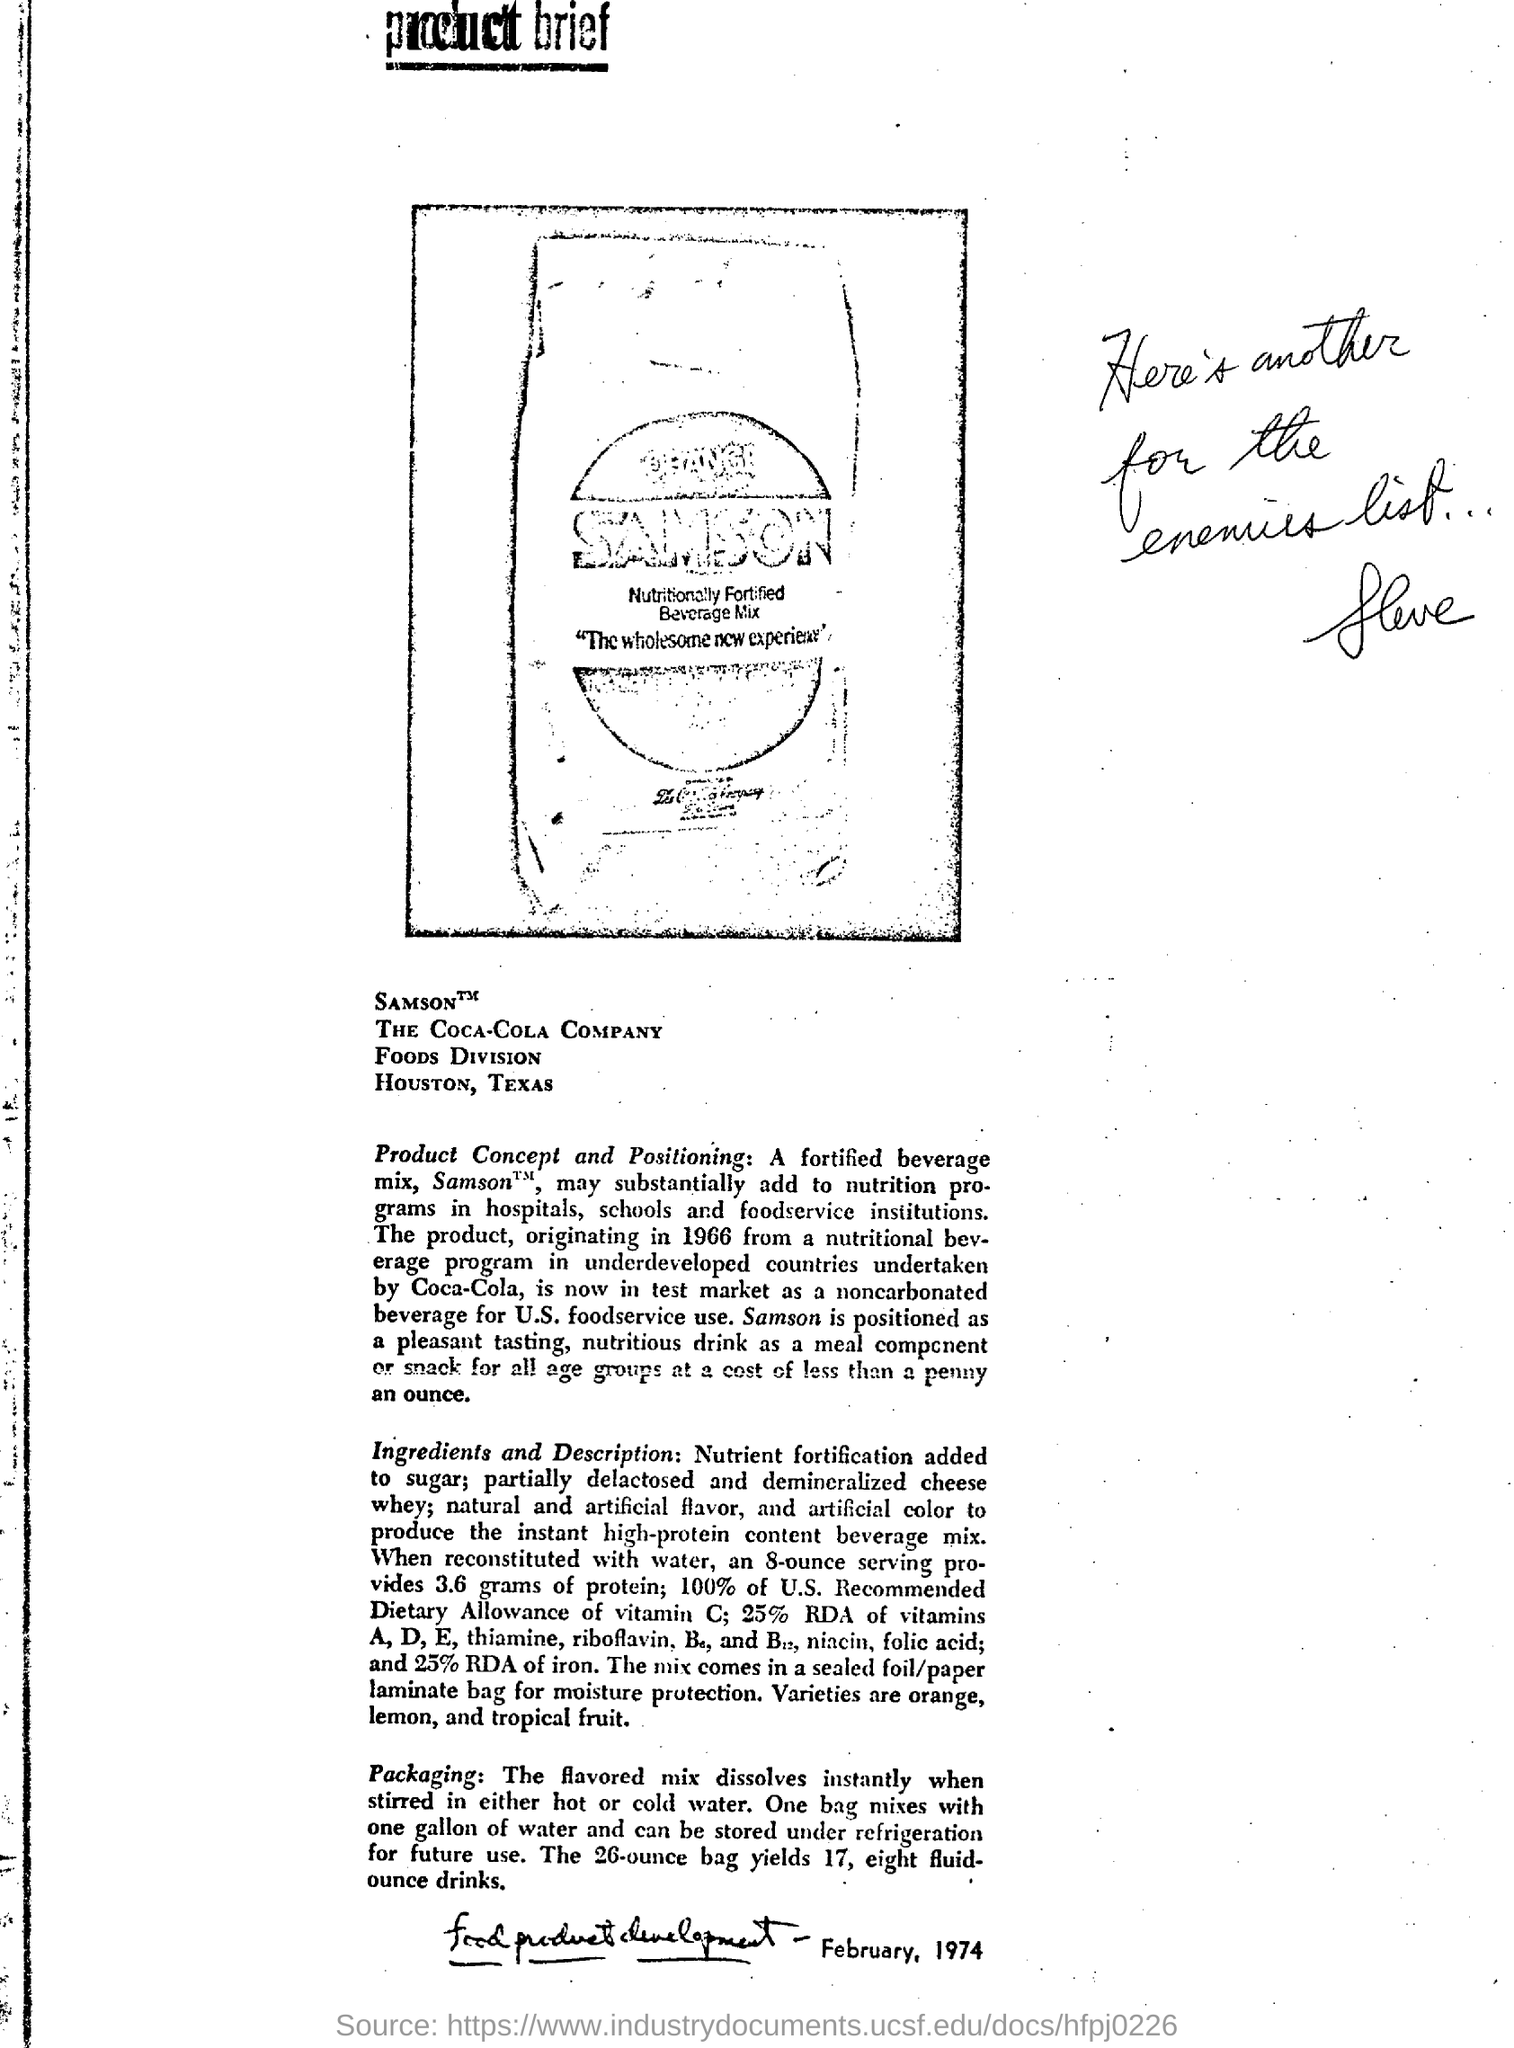Where is the Coca-cola company foods division located?
Offer a terse response. Houston, Texas. 